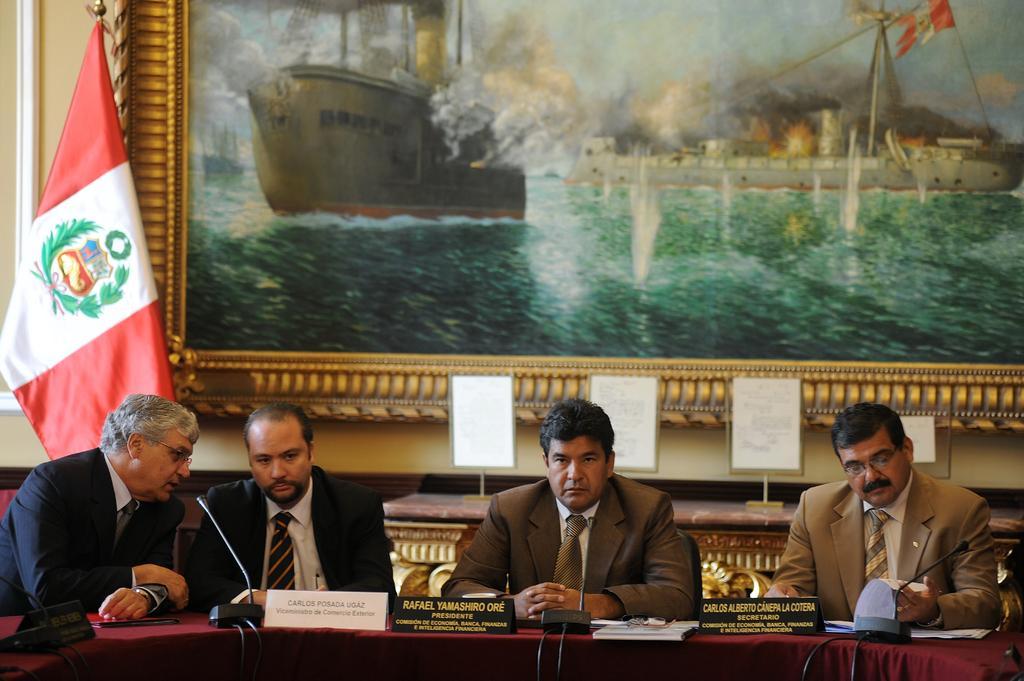Can you describe this image briefly? In this picture, we see four men are sitting on the chairs. In front of them, we see a table on which name boards, microphones, papers and books. Behind them, we see a table on which small white color boards are placed. On the left side, we see a flag in red, white and green color. In the background, we see a wall on which a photo frame is placed. 